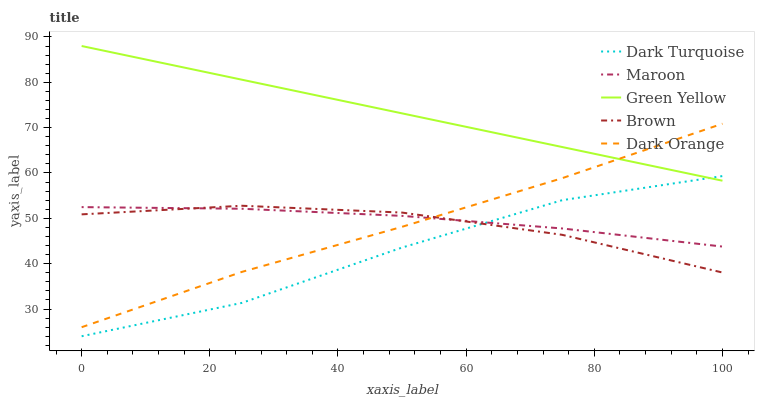Does Dark Turquoise have the minimum area under the curve?
Answer yes or no. Yes. Does Green Yellow have the maximum area under the curve?
Answer yes or no. Yes. Does Green Yellow have the minimum area under the curve?
Answer yes or no. No. Does Dark Turquoise have the maximum area under the curve?
Answer yes or no. No. Is Green Yellow the smoothest?
Answer yes or no. Yes. Is Dark Turquoise the roughest?
Answer yes or no. Yes. Is Dark Turquoise the smoothest?
Answer yes or no. No. Is Green Yellow the roughest?
Answer yes or no. No. Does Dark Turquoise have the lowest value?
Answer yes or no. Yes. Does Green Yellow have the lowest value?
Answer yes or no. No. Does Green Yellow have the highest value?
Answer yes or no. Yes. Does Dark Turquoise have the highest value?
Answer yes or no. No. Is Dark Turquoise less than Dark Orange?
Answer yes or no. Yes. Is Green Yellow greater than Maroon?
Answer yes or no. Yes. Does Brown intersect Maroon?
Answer yes or no. Yes. Is Brown less than Maroon?
Answer yes or no. No. Is Brown greater than Maroon?
Answer yes or no. No. Does Dark Turquoise intersect Dark Orange?
Answer yes or no. No. 